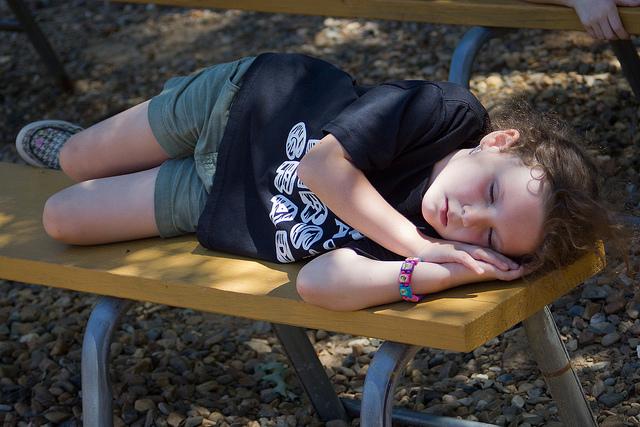Is there someone sleeping on the top part of the picnic table?
Write a very short answer. Yes. Does the child have a bracelet on?
Quick response, please. Yes. What color is her shirt?
Give a very brief answer. Black. Is the child sleeping on a soft surface?
Be succinct. No. 